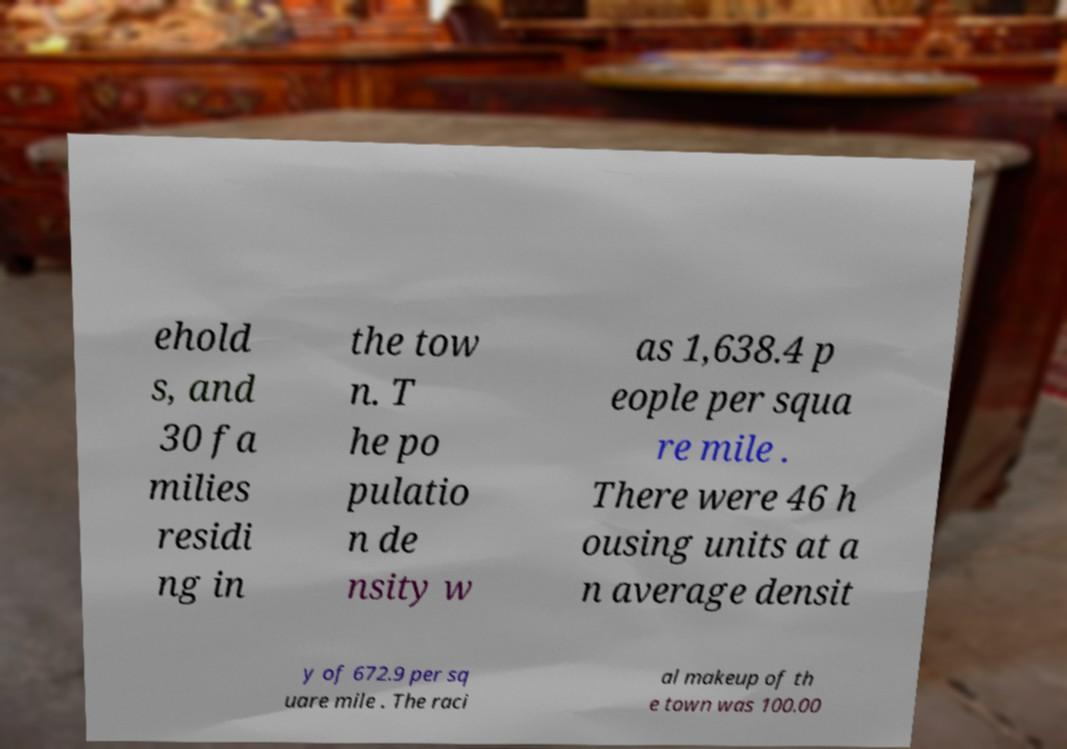There's text embedded in this image that I need extracted. Can you transcribe it verbatim? ehold s, and 30 fa milies residi ng in the tow n. T he po pulatio n de nsity w as 1,638.4 p eople per squa re mile . There were 46 h ousing units at a n average densit y of 672.9 per sq uare mile . The raci al makeup of th e town was 100.00 